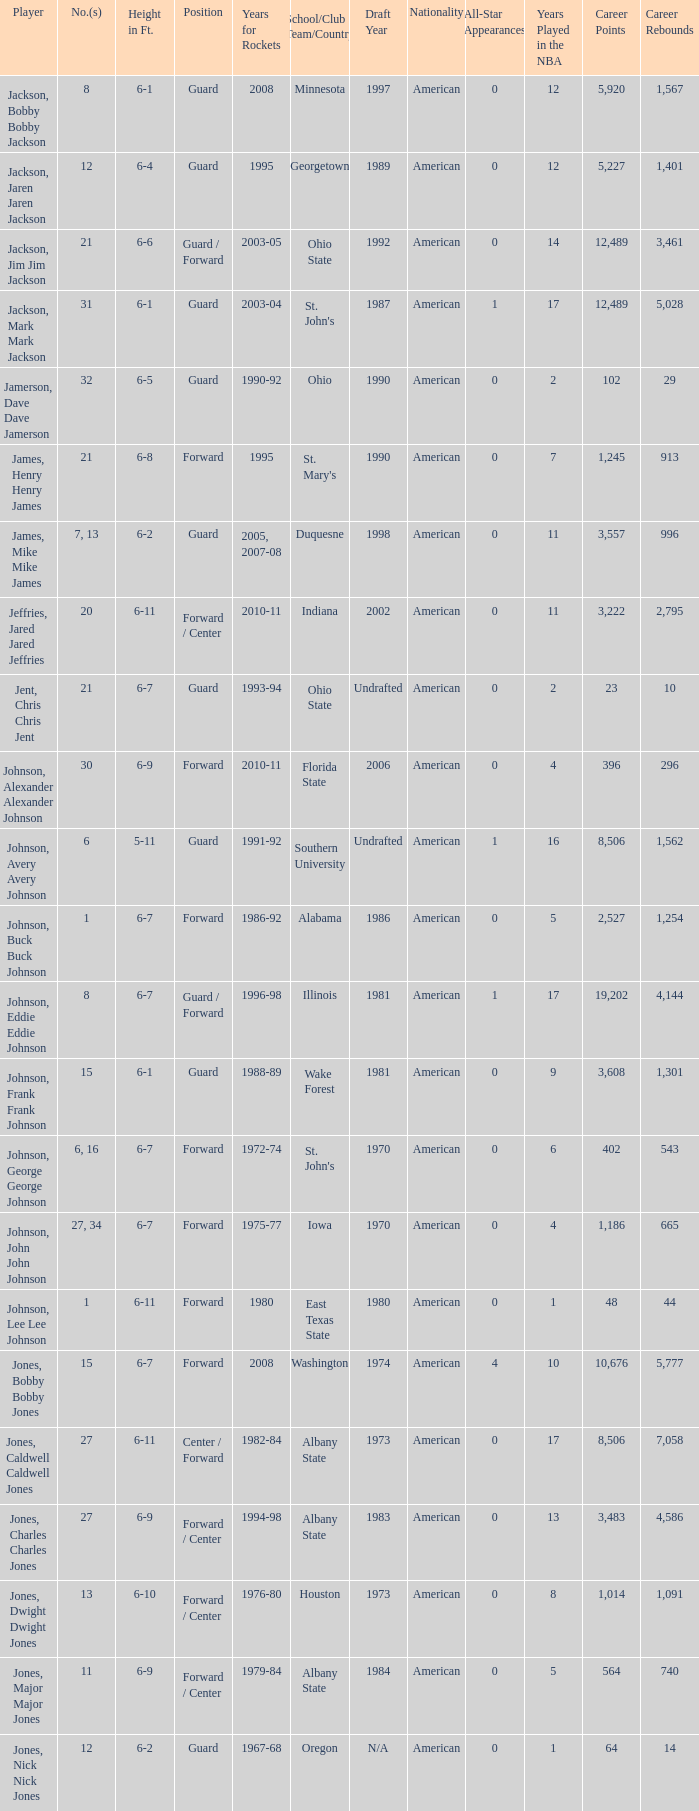What is the quantity of the athlete who attended southern university? 6.0. 